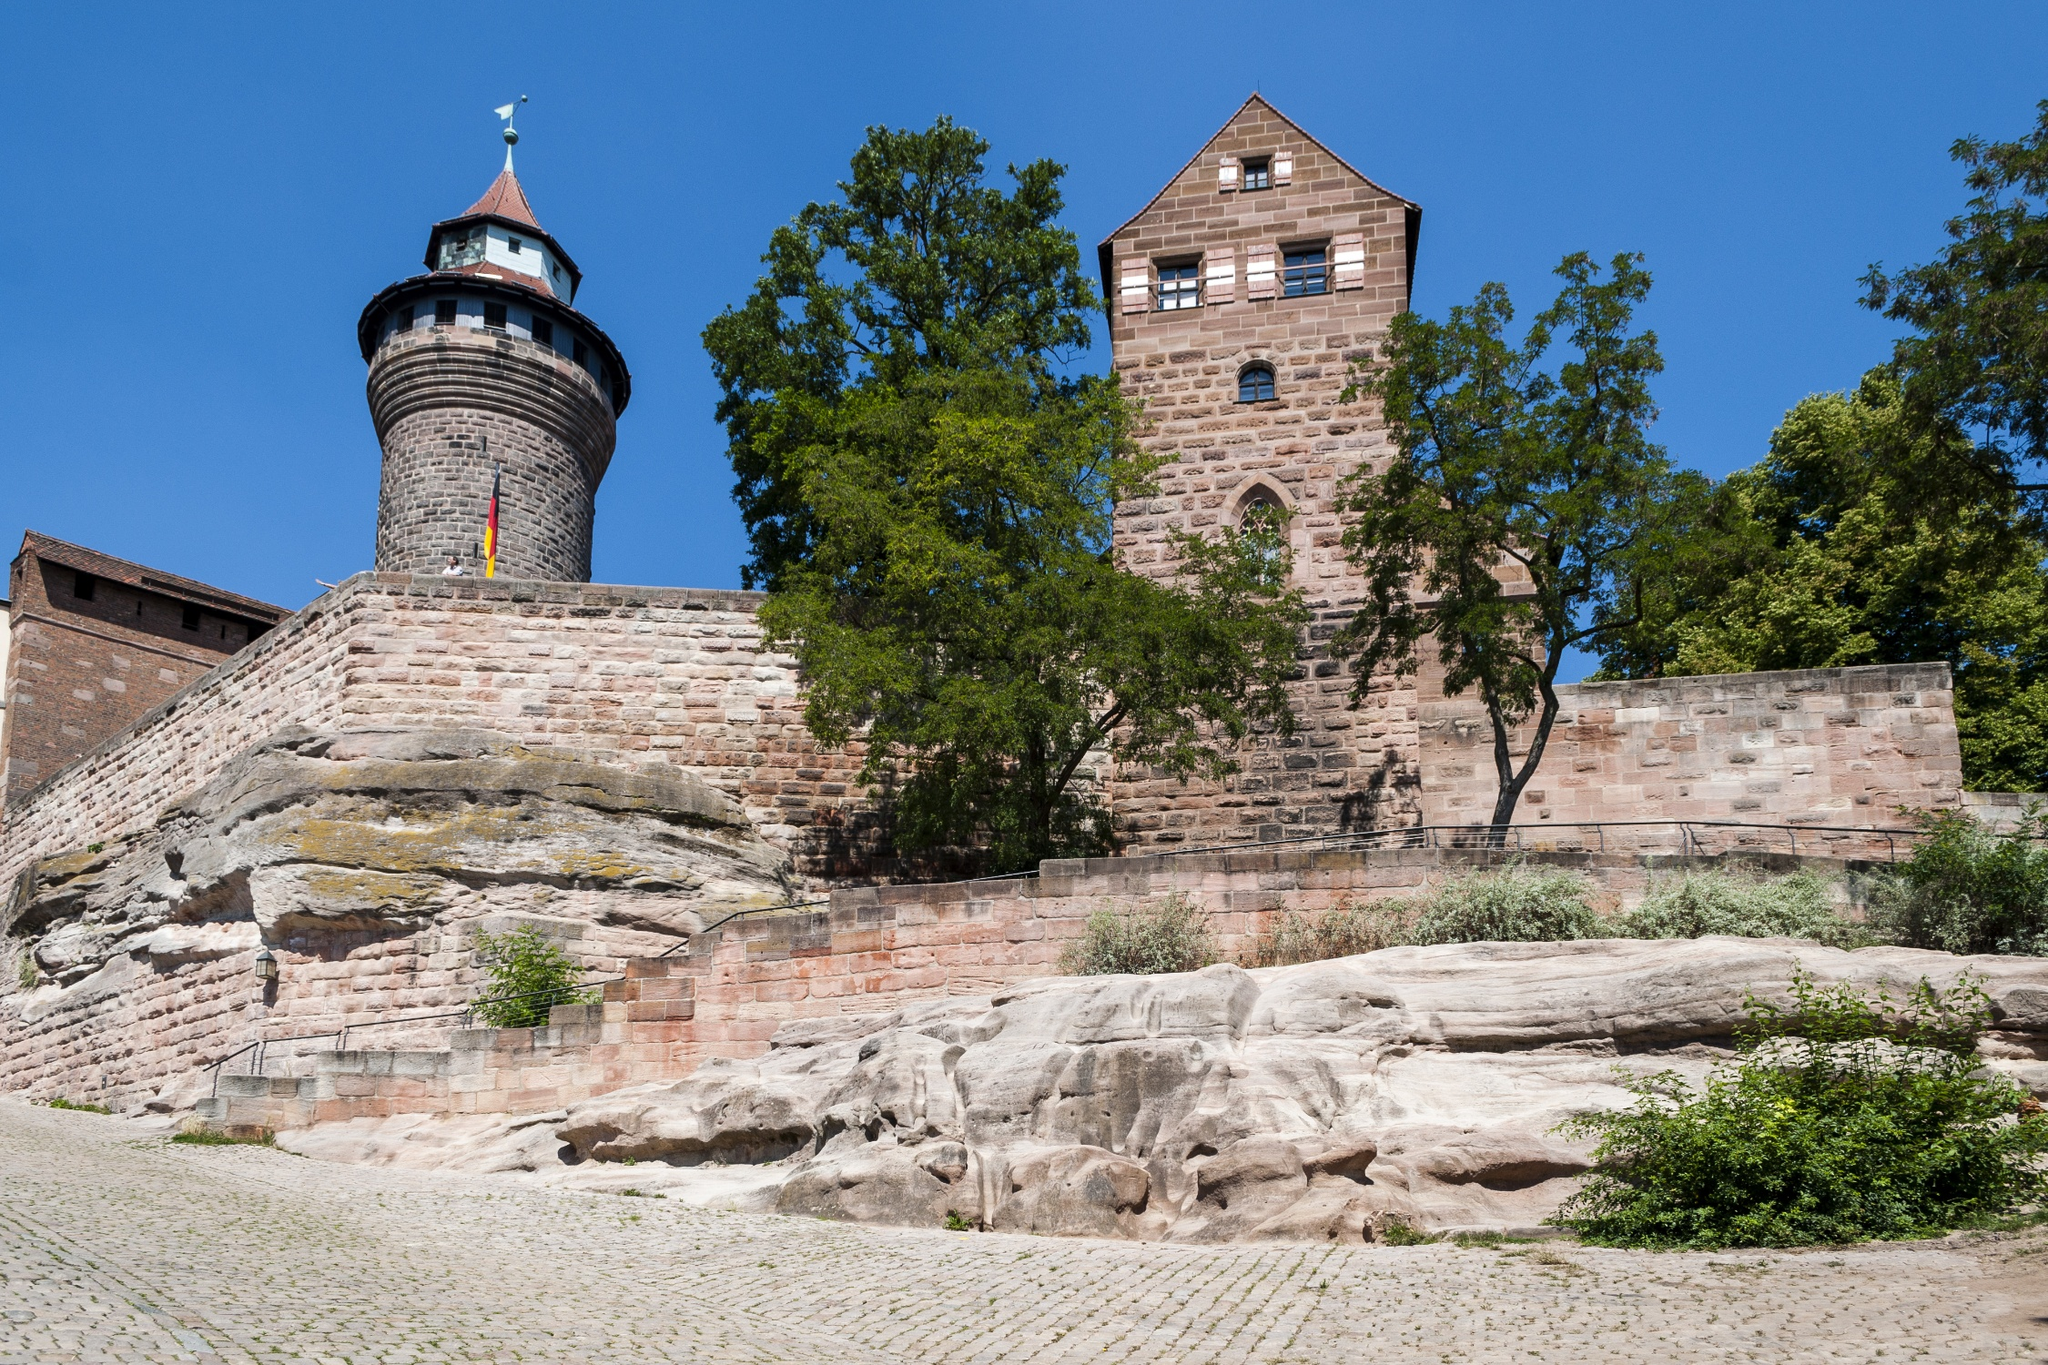What architectural styles are evident in the Kaiserburg Nürnberg? The architecture of Kaiserburg Nürnberg showcases a blend of Romanesque and Gothic styles, characteristic of its time of origin and the subsequent periods through which it was expanded and renovated. The Romanesque style can be seen in the sturdy and heavy structure of the castle, with thick walls and relatively simple, solid spaces designed for defense. Gothic elements were introduced later, evident in the pointed arches and the vertical emphasis seen in the tower constructions. The combination of these styles not only visually appeals but also narrates the evolution of architectural practices in medieval Europe. 